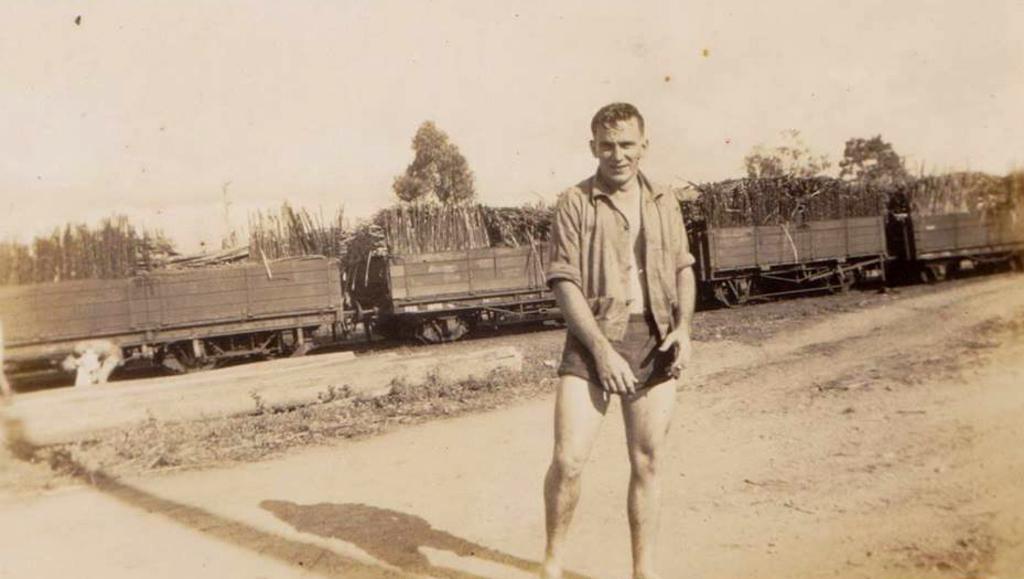Please provide a concise description of this image. In this image there is a person standing and posing for the camera with a smile on his face, behind the person there are coaches of a train with wooden logs in it, in the background of the image there are trees. 